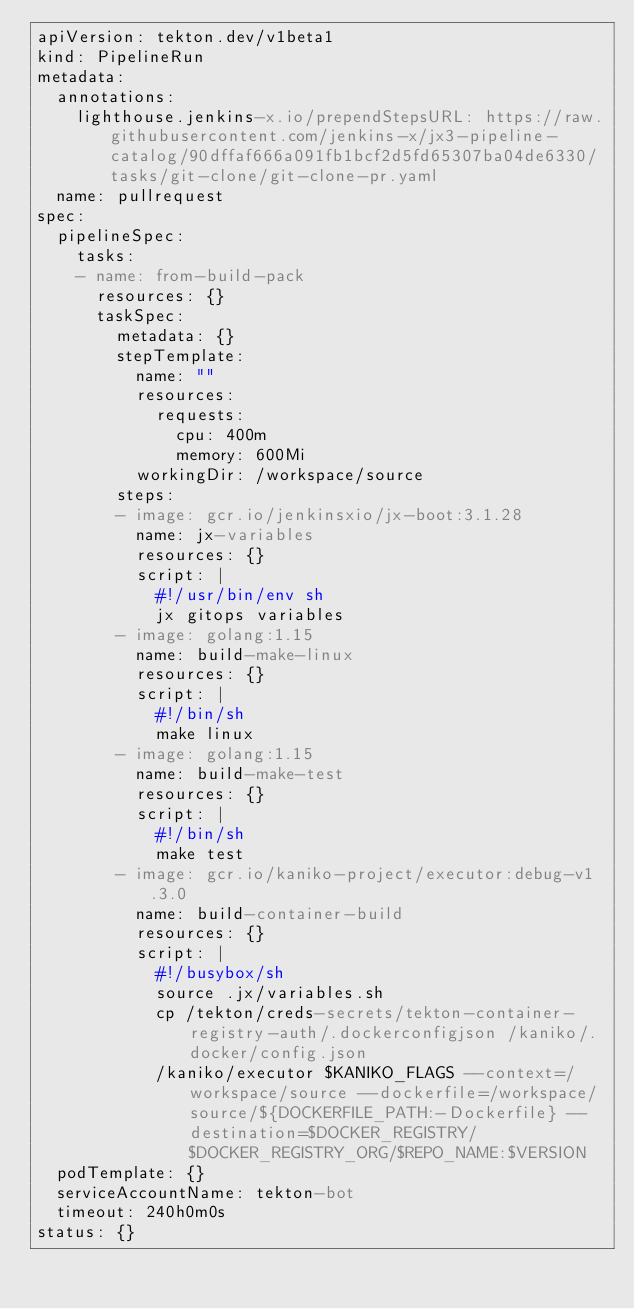Convert code to text. <code><loc_0><loc_0><loc_500><loc_500><_YAML_>apiVersion: tekton.dev/v1beta1
kind: PipelineRun
metadata:
  annotations:
    lighthouse.jenkins-x.io/prependStepsURL: https://raw.githubusercontent.com/jenkins-x/jx3-pipeline-catalog/90dffaf666a091fb1bcf2d5fd65307ba04de6330/tasks/git-clone/git-clone-pr.yaml
  name: pullrequest
spec:
  pipelineSpec:
    tasks:
    - name: from-build-pack
      resources: {}
      taskSpec:
        metadata: {}
        stepTemplate:
          name: ""
          resources:
            requests:
              cpu: 400m
              memory: 600Mi
          workingDir: /workspace/source
        steps:
        - image: gcr.io/jenkinsxio/jx-boot:3.1.28
          name: jx-variables
          resources: {}
          script: |
            #!/usr/bin/env sh
            jx gitops variables
        - image: golang:1.15
          name: build-make-linux
          resources: {}
          script: |
            #!/bin/sh
            make linux
        - image: golang:1.15
          name: build-make-test
          resources: {}
          script: |
            #!/bin/sh
            make test
        - image: gcr.io/kaniko-project/executor:debug-v1.3.0
          name: build-container-build
          resources: {}
          script: |
            #!/busybox/sh
            source .jx/variables.sh
            cp /tekton/creds-secrets/tekton-container-registry-auth/.dockerconfigjson /kaniko/.docker/config.json
            /kaniko/executor $KANIKO_FLAGS --context=/workspace/source --dockerfile=/workspace/source/${DOCKERFILE_PATH:-Dockerfile} --destination=$DOCKER_REGISTRY/$DOCKER_REGISTRY_ORG/$REPO_NAME:$VERSION
  podTemplate: {}
  serviceAccountName: tekton-bot
  timeout: 240h0m0s
status: {}
</code> 